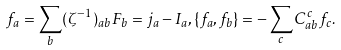Convert formula to latex. <formula><loc_0><loc_0><loc_500><loc_500>f _ { a } = \sum _ { b } ( \zeta ^ { - 1 } ) _ { a b } F _ { b } = j _ { a } - I _ { a } , \{ f _ { a } , f _ { b } \} = - \sum _ { c } C _ { a b } ^ { c } f _ { c } .</formula> 